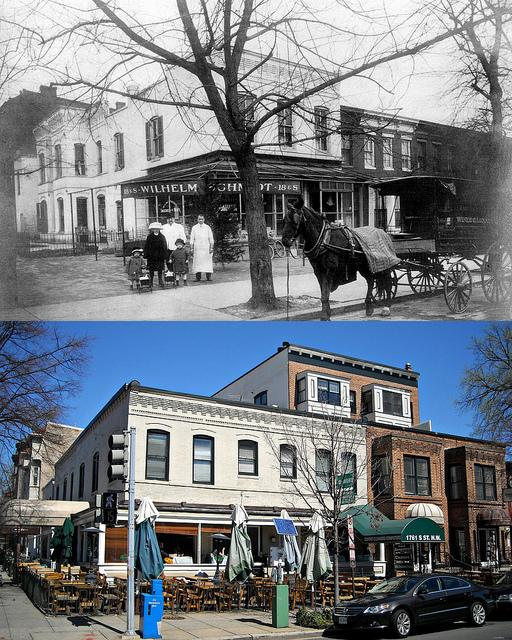Who do the umbrellas belong to? Please explain your reasoning. restaurant. They are part of the restaurant if people want to sit outside. 